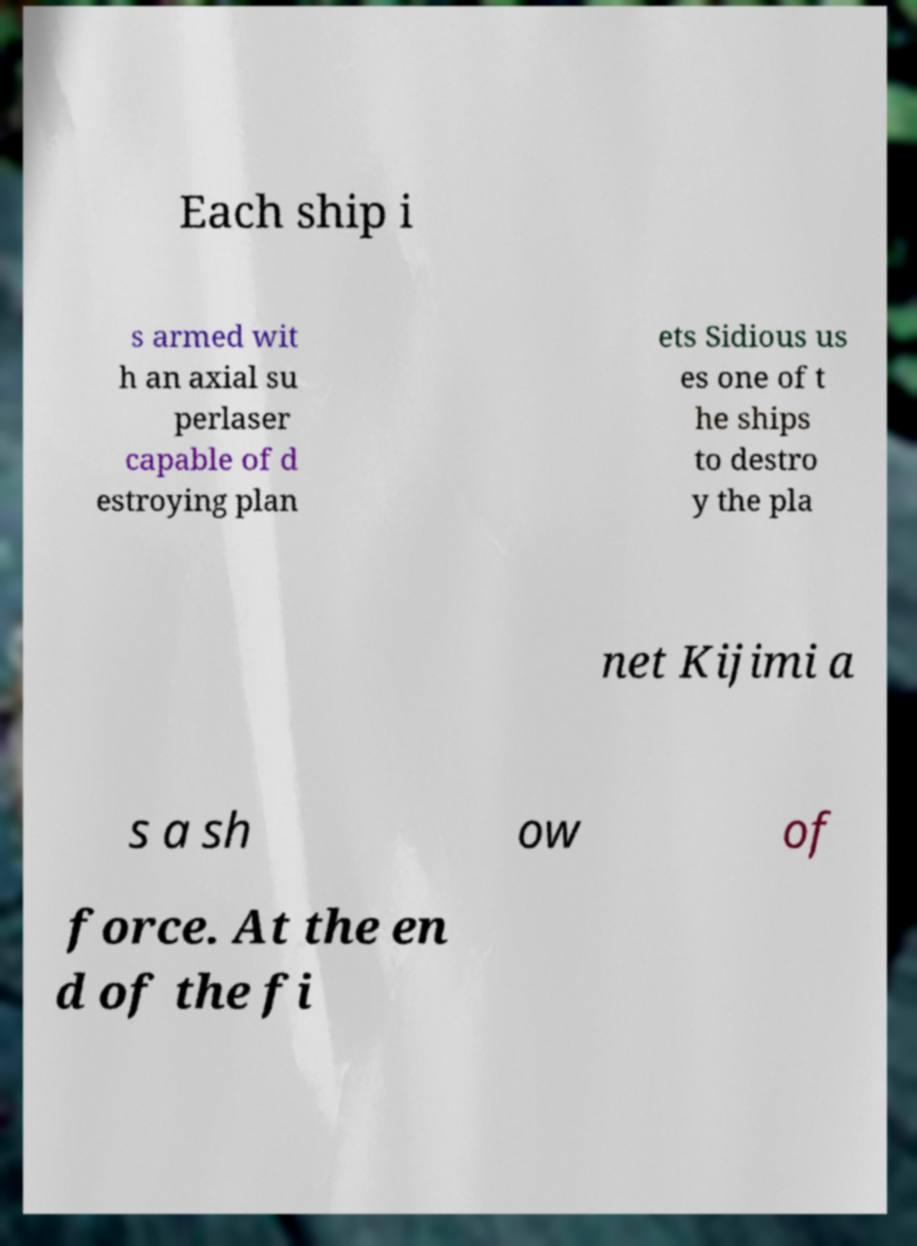Please read and relay the text visible in this image. What does it say? Each ship i s armed wit h an axial su perlaser capable of d estroying plan ets Sidious us es one of t he ships to destro y the pla net Kijimi a s a sh ow of force. At the en d of the fi 